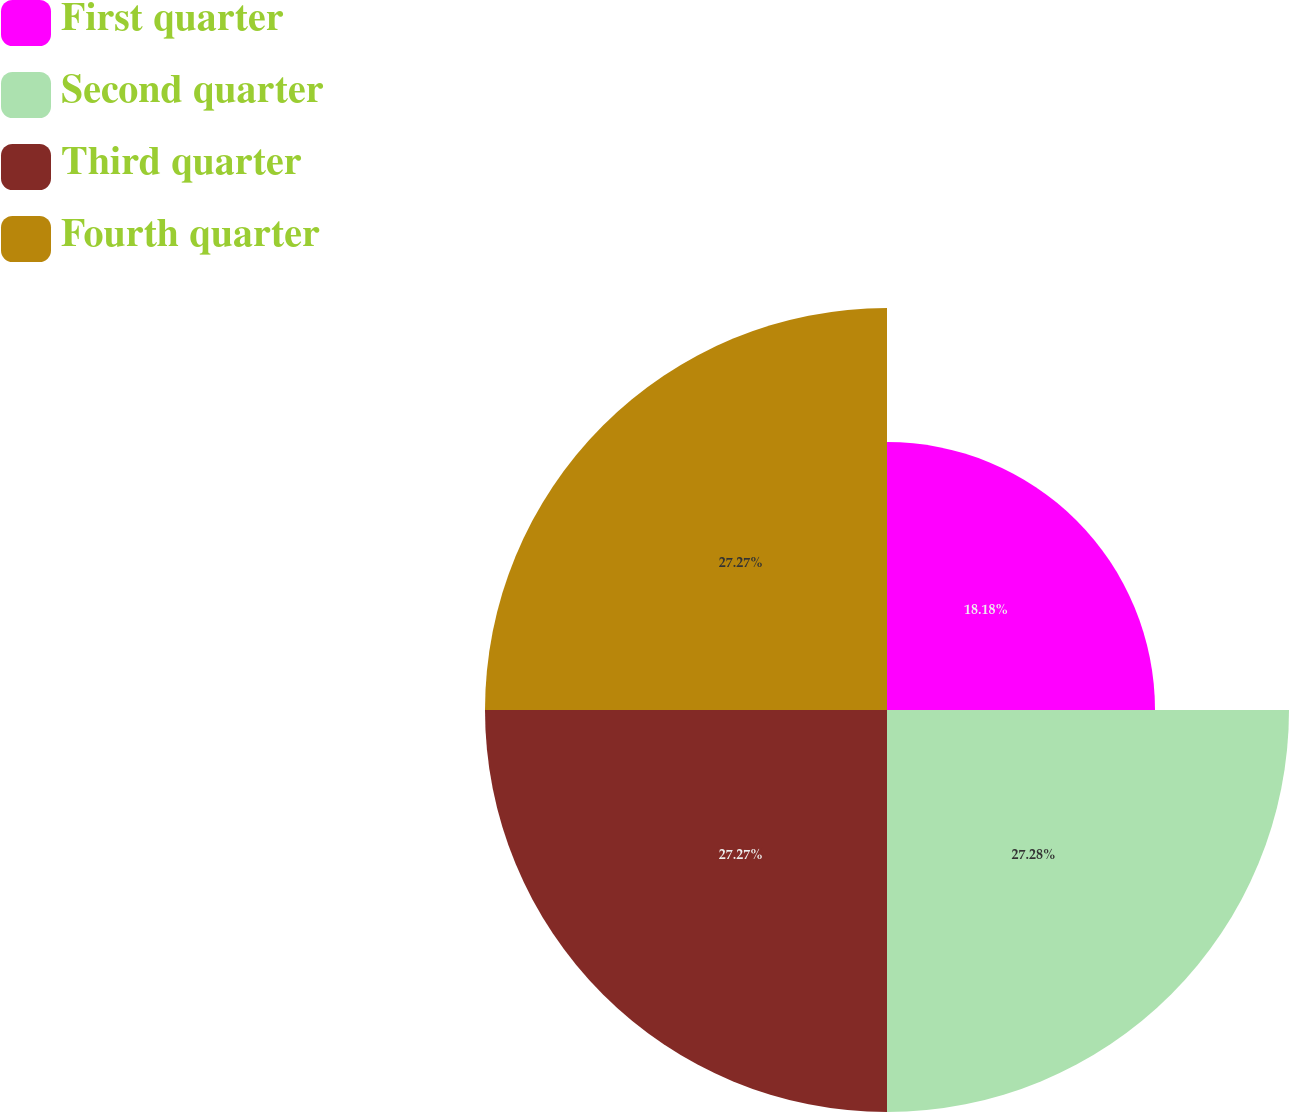<chart> <loc_0><loc_0><loc_500><loc_500><pie_chart><fcel>First quarter<fcel>Second quarter<fcel>Third quarter<fcel>Fourth quarter<nl><fcel>18.18%<fcel>27.27%<fcel>27.27%<fcel>27.27%<nl></chart> 